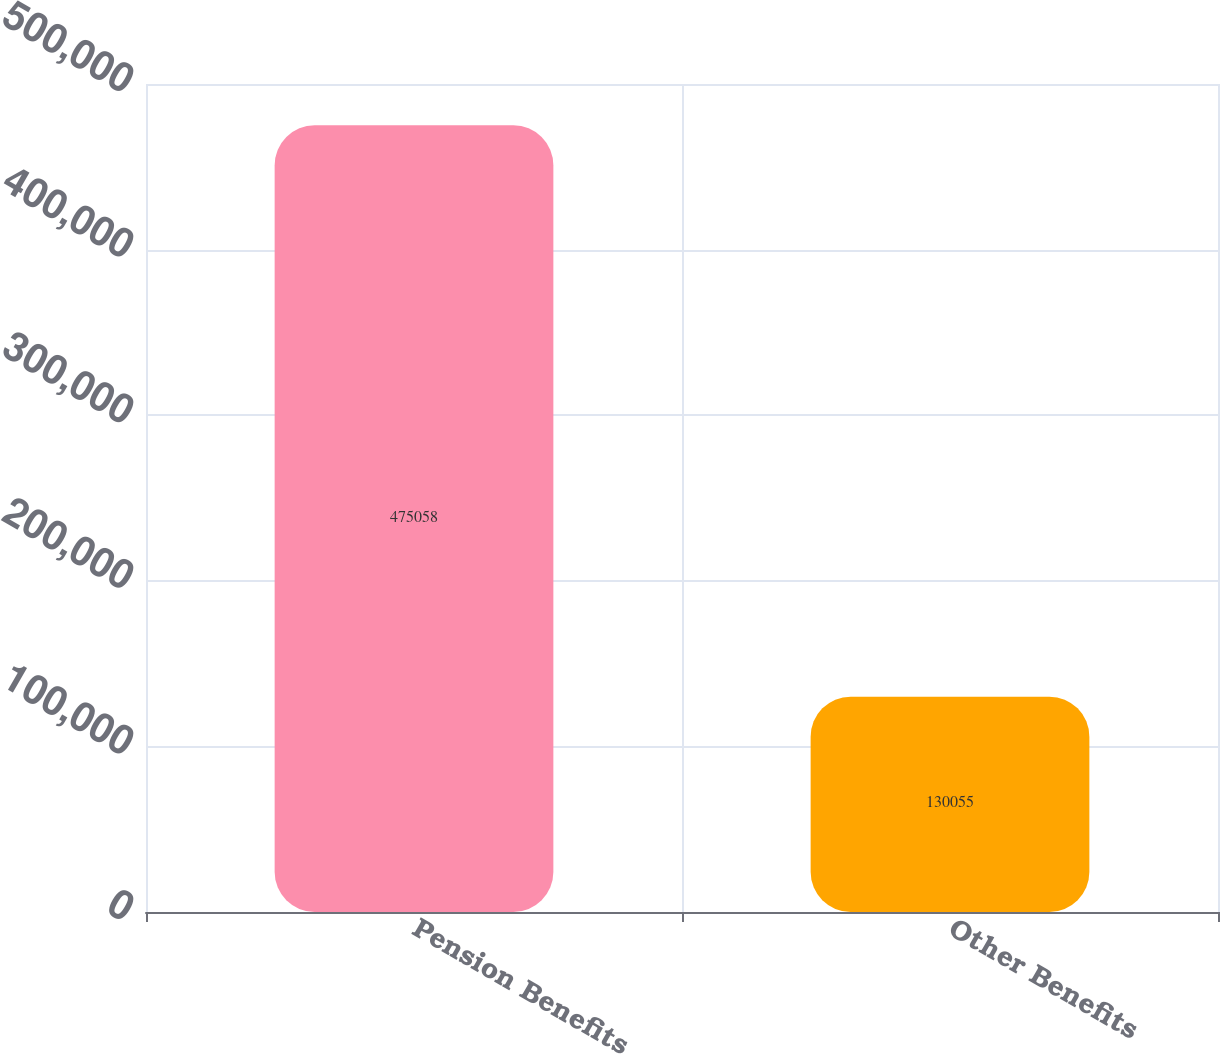<chart> <loc_0><loc_0><loc_500><loc_500><bar_chart><fcel>Pension Benefits<fcel>Other Benefits<nl><fcel>475058<fcel>130055<nl></chart> 